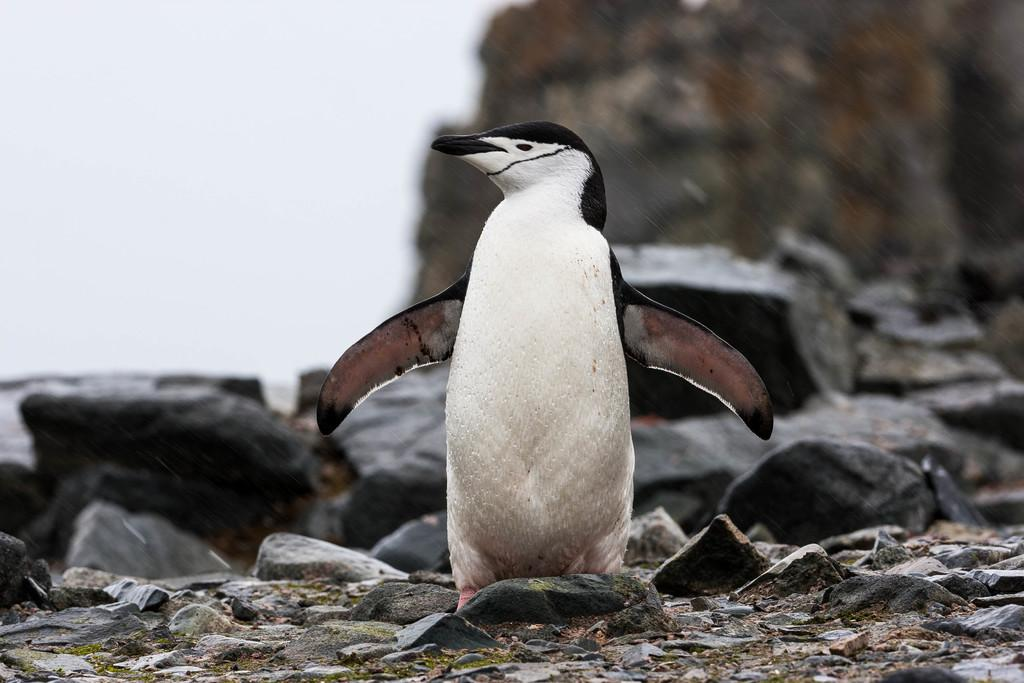What is the main subject in the center of the image? There is a penguin in the center of the image. What colors can be seen on the penguin? The penguin is black and white in color. What type of natural elements are visible in the image? There are stones visible in the image. Can you describe the background of the image? The background of the image is blurred. Where is the pump located in the image? There is no pump present in the image. What type of food is being served in the lunchroom in the image? There is no lunchroom present in the image. 